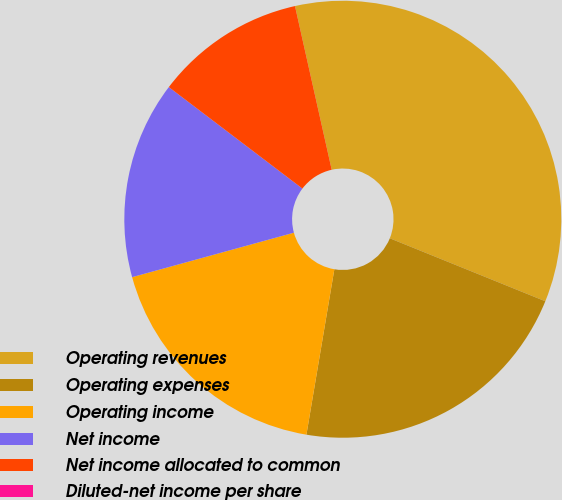<chart> <loc_0><loc_0><loc_500><loc_500><pie_chart><fcel>Operating revenues<fcel>Operating expenses<fcel>Operating income<fcel>Net income<fcel>Net income allocated to common<fcel>Diluted-net income per share<nl><fcel>34.64%<fcel>21.54%<fcel>18.07%<fcel>14.61%<fcel>11.15%<fcel>0.0%<nl></chart> 